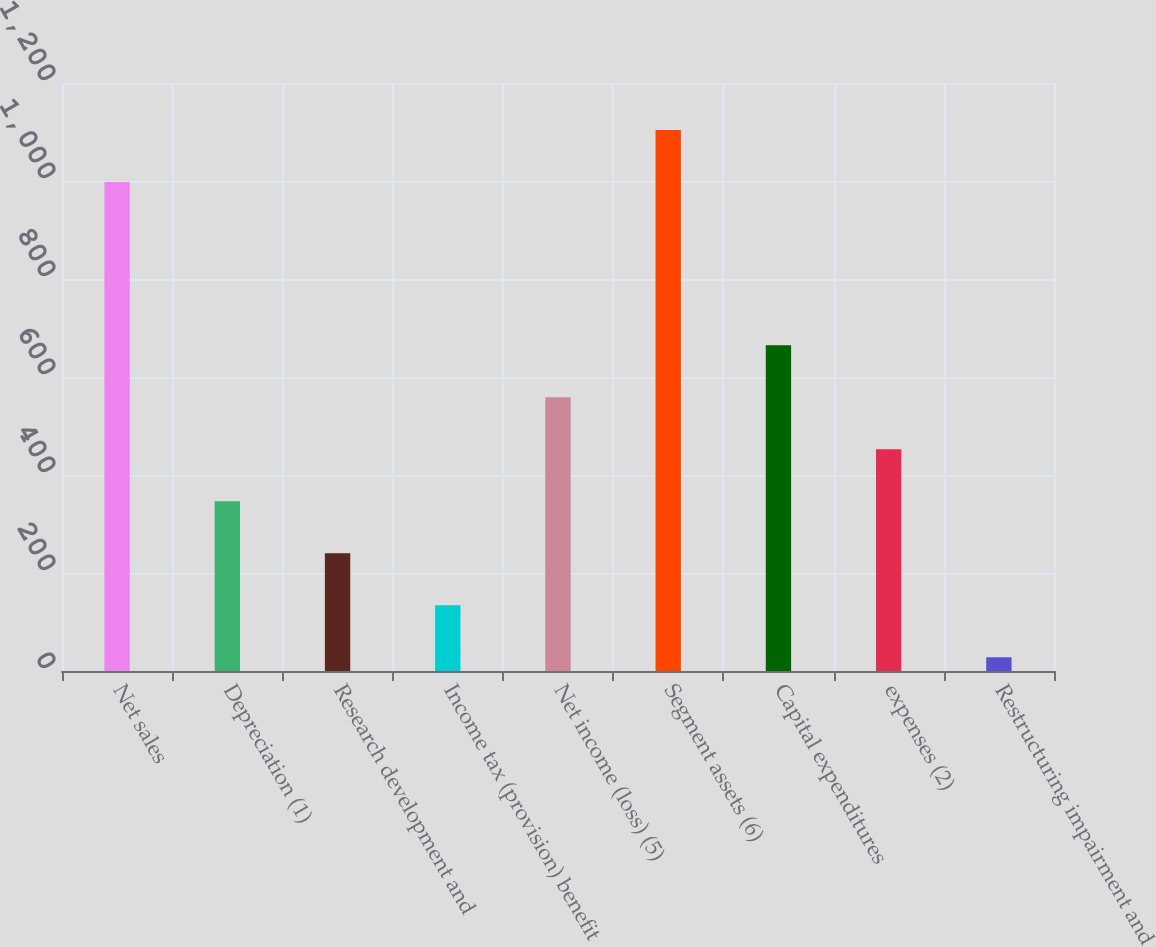Convert chart. <chart><loc_0><loc_0><loc_500><loc_500><bar_chart><fcel>Net sales<fcel>Depreciation (1)<fcel>Research development and<fcel>Income tax (provision) benefit<fcel>Net income (loss) (5)<fcel>Segment assets (6)<fcel>Capital expenditures<fcel>expenses (2)<fcel>Restructuring impairment and<nl><fcel>998<fcel>346.3<fcel>240.2<fcel>134.1<fcel>558.5<fcel>1104.1<fcel>664.6<fcel>452.4<fcel>28<nl></chart> 